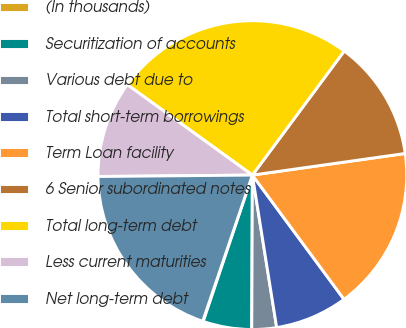<chart> <loc_0><loc_0><loc_500><loc_500><pie_chart><fcel>(In thousands)<fcel>Securitization of accounts<fcel>Various debt due to<fcel>Total short-term borrowings<fcel>Term Loan facility<fcel>6 Senior subordinated notes<fcel>Total long-term debt<fcel>Less current maturities<fcel>Net long-term debt<nl><fcel>0.06%<fcel>5.09%<fcel>2.58%<fcel>7.6%<fcel>17.12%<fcel>12.62%<fcel>25.18%<fcel>10.11%<fcel>19.64%<nl></chart> 